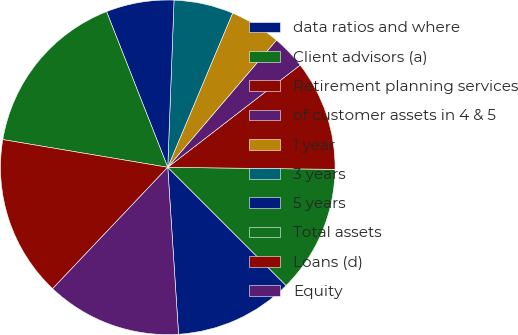Convert chart. <chart><loc_0><loc_0><loc_500><loc_500><pie_chart><fcel>data ratios and where<fcel>Client advisors (a)<fcel>Retirement planning services<fcel>of customer assets in 4 & 5<fcel>1 year<fcel>3 years<fcel>5 years<fcel>Total assets<fcel>Loans (d)<fcel>Equity<nl><fcel>11.48%<fcel>12.3%<fcel>10.66%<fcel>3.28%<fcel>4.92%<fcel>5.74%<fcel>6.56%<fcel>16.39%<fcel>15.57%<fcel>13.11%<nl></chart> 